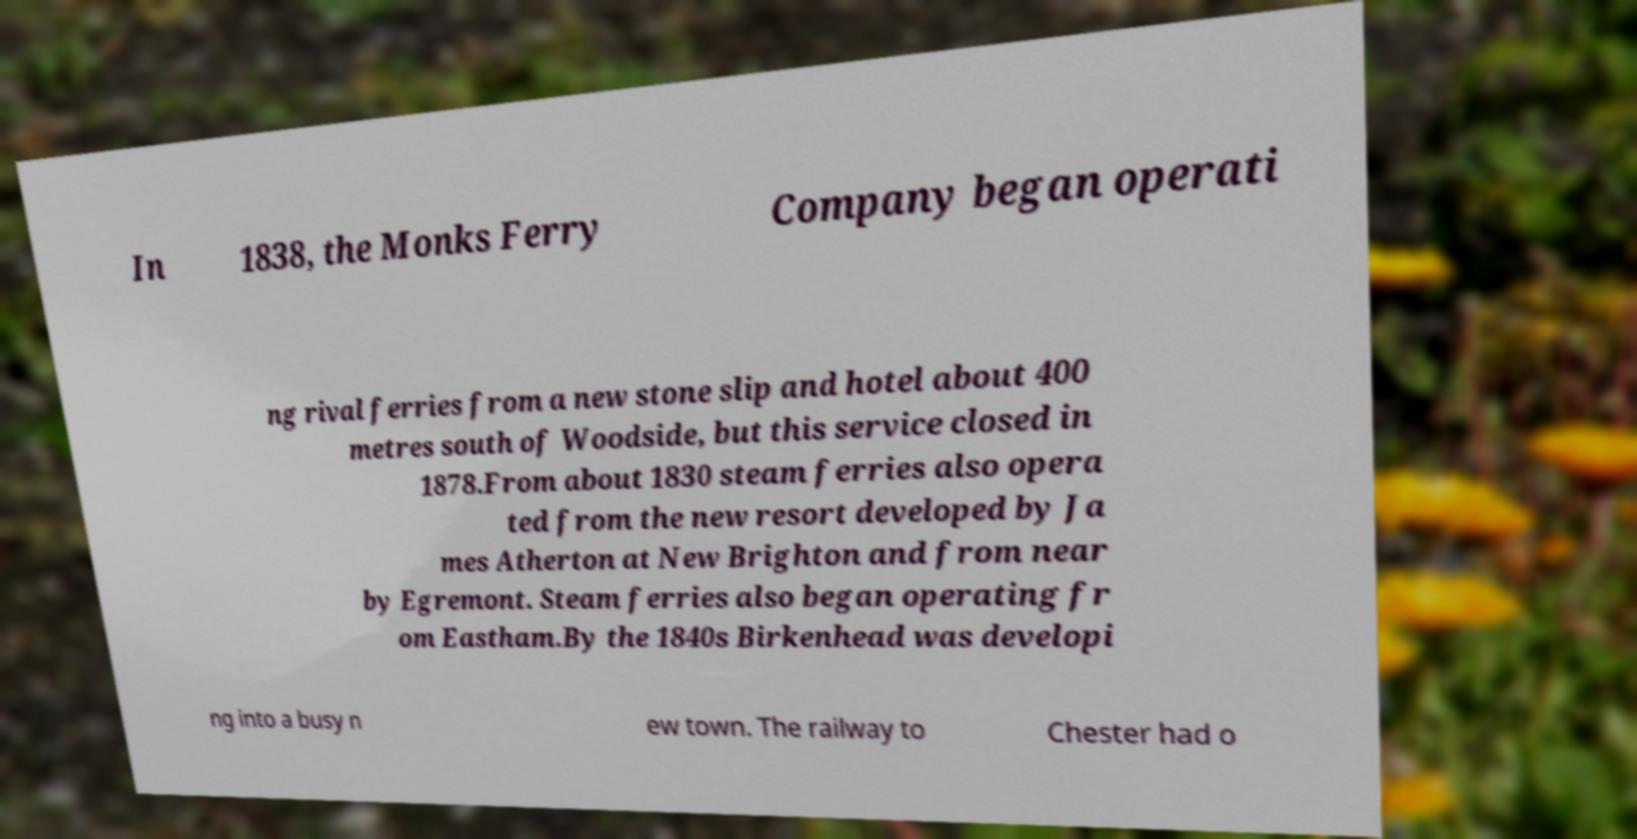I need the written content from this picture converted into text. Can you do that? In 1838, the Monks Ferry Company began operati ng rival ferries from a new stone slip and hotel about 400 metres south of Woodside, but this service closed in 1878.From about 1830 steam ferries also opera ted from the new resort developed by Ja mes Atherton at New Brighton and from near by Egremont. Steam ferries also began operating fr om Eastham.By the 1840s Birkenhead was developi ng into a busy n ew town. The railway to Chester had o 